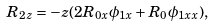Convert formula to latex. <formula><loc_0><loc_0><loc_500><loc_500>R _ { 2 z } = - z ( 2 R _ { 0 x } \phi _ { 1 x } + R _ { 0 } \phi _ { 1 x x } ) ,</formula> 